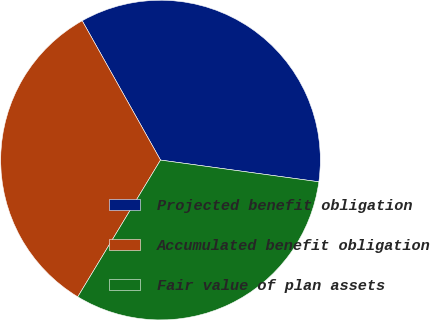Convert chart to OTSL. <chart><loc_0><loc_0><loc_500><loc_500><pie_chart><fcel>Projected benefit obligation<fcel>Accumulated benefit obligation<fcel>Fair value of plan assets<nl><fcel>35.32%<fcel>33.19%<fcel>31.49%<nl></chart> 